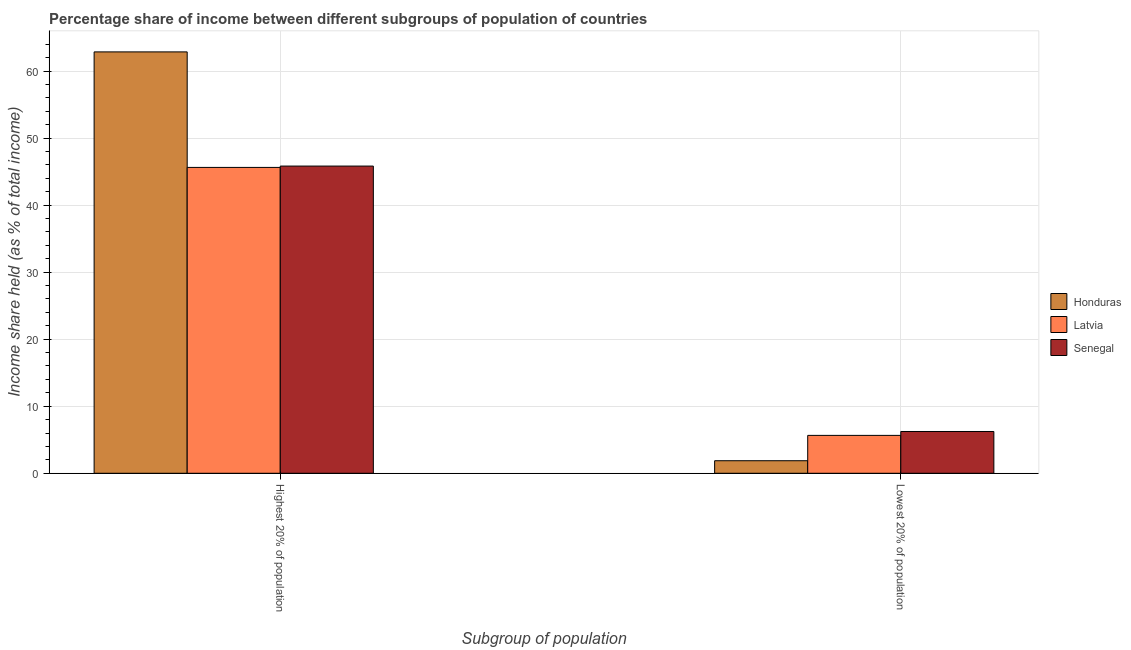How many groups of bars are there?
Give a very brief answer. 2. Are the number of bars on each tick of the X-axis equal?
Provide a short and direct response. Yes. How many bars are there on the 2nd tick from the right?
Ensure brevity in your answer.  3. What is the label of the 1st group of bars from the left?
Offer a terse response. Highest 20% of population. What is the income share held by lowest 20% of the population in Senegal?
Give a very brief answer. 6.23. Across all countries, what is the maximum income share held by lowest 20% of the population?
Keep it short and to the point. 6.23. Across all countries, what is the minimum income share held by highest 20% of the population?
Your response must be concise. 45.62. In which country was the income share held by highest 20% of the population maximum?
Make the answer very short. Honduras. In which country was the income share held by lowest 20% of the population minimum?
Offer a terse response. Honduras. What is the total income share held by lowest 20% of the population in the graph?
Your answer should be compact. 13.75. What is the difference between the income share held by highest 20% of the population in Latvia and that in Honduras?
Make the answer very short. -17.23. What is the difference between the income share held by lowest 20% of the population in Honduras and the income share held by highest 20% of the population in Senegal?
Offer a terse response. -43.95. What is the average income share held by highest 20% of the population per country?
Offer a very short reply. 51.43. What is the difference between the income share held by lowest 20% of the population and income share held by highest 20% of the population in Latvia?
Give a very brief answer. -39.97. What is the ratio of the income share held by highest 20% of the population in Latvia to that in Honduras?
Keep it short and to the point. 0.73. What does the 3rd bar from the left in Lowest 20% of population represents?
Offer a very short reply. Senegal. What does the 3rd bar from the right in Highest 20% of population represents?
Provide a succinct answer. Honduras. Are all the bars in the graph horizontal?
Your answer should be compact. No. How many countries are there in the graph?
Give a very brief answer. 3. How many legend labels are there?
Your answer should be very brief. 3. How are the legend labels stacked?
Provide a short and direct response. Vertical. What is the title of the graph?
Keep it short and to the point. Percentage share of income between different subgroups of population of countries. Does "Niger" appear as one of the legend labels in the graph?
Provide a succinct answer. No. What is the label or title of the X-axis?
Provide a succinct answer. Subgroup of population. What is the label or title of the Y-axis?
Keep it short and to the point. Income share held (as % of total income). What is the Income share held (as % of total income) of Honduras in Highest 20% of population?
Give a very brief answer. 62.85. What is the Income share held (as % of total income) of Latvia in Highest 20% of population?
Make the answer very short. 45.62. What is the Income share held (as % of total income) in Senegal in Highest 20% of population?
Ensure brevity in your answer.  45.82. What is the Income share held (as % of total income) in Honduras in Lowest 20% of population?
Your answer should be very brief. 1.87. What is the Income share held (as % of total income) of Latvia in Lowest 20% of population?
Ensure brevity in your answer.  5.65. What is the Income share held (as % of total income) of Senegal in Lowest 20% of population?
Give a very brief answer. 6.23. Across all Subgroup of population, what is the maximum Income share held (as % of total income) in Honduras?
Ensure brevity in your answer.  62.85. Across all Subgroup of population, what is the maximum Income share held (as % of total income) in Latvia?
Give a very brief answer. 45.62. Across all Subgroup of population, what is the maximum Income share held (as % of total income) of Senegal?
Offer a terse response. 45.82. Across all Subgroup of population, what is the minimum Income share held (as % of total income) in Honduras?
Offer a terse response. 1.87. Across all Subgroup of population, what is the minimum Income share held (as % of total income) of Latvia?
Your answer should be compact. 5.65. Across all Subgroup of population, what is the minimum Income share held (as % of total income) of Senegal?
Ensure brevity in your answer.  6.23. What is the total Income share held (as % of total income) in Honduras in the graph?
Make the answer very short. 64.72. What is the total Income share held (as % of total income) in Latvia in the graph?
Give a very brief answer. 51.27. What is the total Income share held (as % of total income) of Senegal in the graph?
Provide a short and direct response. 52.05. What is the difference between the Income share held (as % of total income) of Honduras in Highest 20% of population and that in Lowest 20% of population?
Give a very brief answer. 60.98. What is the difference between the Income share held (as % of total income) of Latvia in Highest 20% of population and that in Lowest 20% of population?
Offer a very short reply. 39.97. What is the difference between the Income share held (as % of total income) of Senegal in Highest 20% of population and that in Lowest 20% of population?
Offer a very short reply. 39.59. What is the difference between the Income share held (as % of total income) of Honduras in Highest 20% of population and the Income share held (as % of total income) of Latvia in Lowest 20% of population?
Your response must be concise. 57.2. What is the difference between the Income share held (as % of total income) in Honduras in Highest 20% of population and the Income share held (as % of total income) in Senegal in Lowest 20% of population?
Provide a short and direct response. 56.62. What is the difference between the Income share held (as % of total income) of Latvia in Highest 20% of population and the Income share held (as % of total income) of Senegal in Lowest 20% of population?
Ensure brevity in your answer.  39.39. What is the average Income share held (as % of total income) of Honduras per Subgroup of population?
Your answer should be very brief. 32.36. What is the average Income share held (as % of total income) of Latvia per Subgroup of population?
Give a very brief answer. 25.64. What is the average Income share held (as % of total income) in Senegal per Subgroup of population?
Give a very brief answer. 26.02. What is the difference between the Income share held (as % of total income) of Honduras and Income share held (as % of total income) of Latvia in Highest 20% of population?
Provide a short and direct response. 17.23. What is the difference between the Income share held (as % of total income) in Honduras and Income share held (as % of total income) in Senegal in Highest 20% of population?
Your answer should be very brief. 17.03. What is the difference between the Income share held (as % of total income) of Honduras and Income share held (as % of total income) of Latvia in Lowest 20% of population?
Your answer should be compact. -3.78. What is the difference between the Income share held (as % of total income) in Honduras and Income share held (as % of total income) in Senegal in Lowest 20% of population?
Your answer should be very brief. -4.36. What is the difference between the Income share held (as % of total income) of Latvia and Income share held (as % of total income) of Senegal in Lowest 20% of population?
Provide a short and direct response. -0.58. What is the ratio of the Income share held (as % of total income) in Honduras in Highest 20% of population to that in Lowest 20% of population?
Your response must be concise. 33.61. What is the ratio of the Income share held (as % of total income) of Latvia in Highest 20% of population to that in Lowest 20% of population?
Give a very brief answer. 8.07. What is the ratio of the Income share held (as % of total income) in Senegal in Highest 20% of population to that in Lowest 20% of population?
Provide a succinct answer. 7.35. What is the difference between the highest and the second highest Income share held (as % of total income) of Honduras?
Provide a succinct answer. 60.98. What is the difference between the highest and the second highest Income share held (as % of total income) of Latvia?
Make the answer very short. 39.97. What is the difference between the highest and the second highest Income share held (as % of total income) of Senegal?
Offer a terse response. 39.59. What is the difference between the highest and the lowest Income share held (as % of total income) of Honduras?
Your answer should be very brief. 60.98. What is the difference between the highest and the lowest Income share held (as % of total income) in Latvia?
Offer a terse response. 39.97. What is the difference between the highest and the lowest Income share held (as % of total income) in Senegal?
Keep it short and to the point. 39.59. 